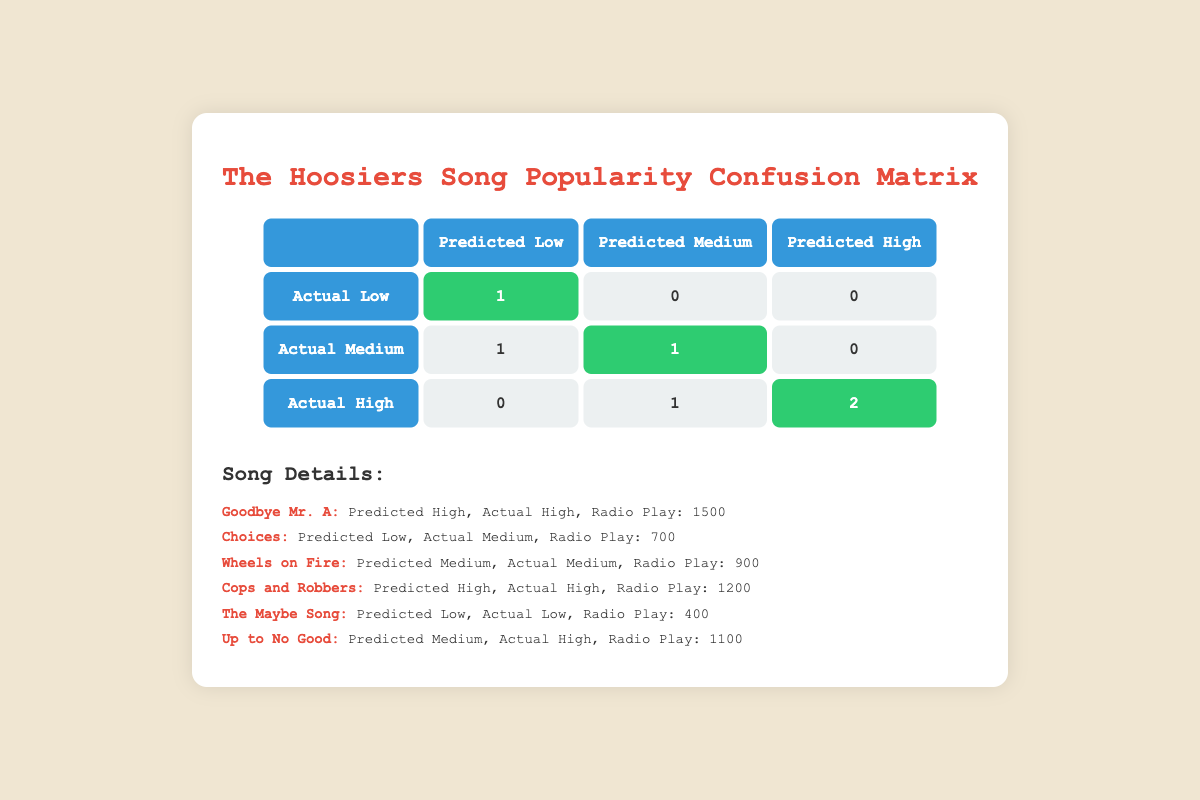What is the number of songs predicted to be of high popularity that were actually of high popularity? The table indicates that there are two songs predicted to be of high popularity that were also actually of high popularity: "Goodbye Mr. A" and "Cops and Robbers." Thus, the total count is 2.
Answer: 2 How many songs are predicted to be of low popularity and were actually of low popularity? Only one song, "The Maybe Song," is recorded in the confusion matrix as predicted low and actually low. Therefore, the answer is 1.
Answer: 1 What is the sum of songs predicted to be of medium popularity that were actually of medium popularity? The table shows that 1 song ("Wheels on Fire") is predicted medium and actually medium. The total sum is thus 1.
Answer: 1 Are there any songs predicted to be of high popularity that were actually of low popularity? By examining the table, none of the songs predicted to be of high popularity were actually classified as low popularity, confirming the statement as false.
Answer: No What is the total number of songs in the dataset? The dataset provides details on six songs, which can be directly counted from the list presented in the table. Thus, the total number is 6.
Answer: 6 How many songs have been predicted as medium popularity? There are two songs predicted to be of medium popularity: "Wheels on Fire" and "Up to No Good." Therefore, the count is 2.
Answer: 2 What fraction of the songs predicted to be low in popularity were actually of medium popularity? There is 1 song predicted low that is actually medium ("Choices"). Since there are 2 songs predicted low (1 is actual low, 1 actual medium), the fraction is 1/2.
Answer: 1/2 How many songs had radio play of 700 or more but were predicted to be low? From the table, only "Choices" has radio play of 700 and is predicted to be low. Since that's only one song, the answer is 1.
Answer: 1 Which predicted popularity category has the highest number of songs that matched their actual popularity? Both "High" and "Medium" categories have a matching count of 2 songs, but "High" has more songs getting the actual popularity while "Low" has only 1. Therefore, it is "High."
Answer: High 